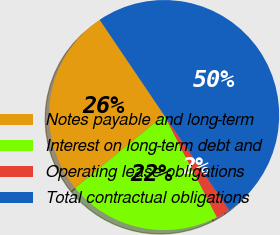Convert chart to OTSL. <chart><loc_0><loc_0><loc_500><loc_500><pie_chart><fcel>Notes payable and long-term<fcel>Interest on long-term debt and<fcel>Operating lease obligations<fcel>Total contractual obligations<nl><fcel>26.47%<fcel>21.68%<fcel>1.95%<fcel>49.91%<nl></chart> 